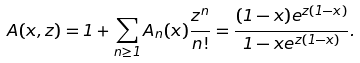Convert formula to latex. <formula><loc_0><loc_0><loc_500><loc_500>A ( x , z ) = 1 + \sum _ { n \geq 1 } A _ { n } ( x ) \frac { z ^ { n } } { n ! } = \frac { ( 1 - x ) e ^ { z ( 1 - x ) } } { 1 - x e ^ { z ( 1 - x ) } } .</formula> 